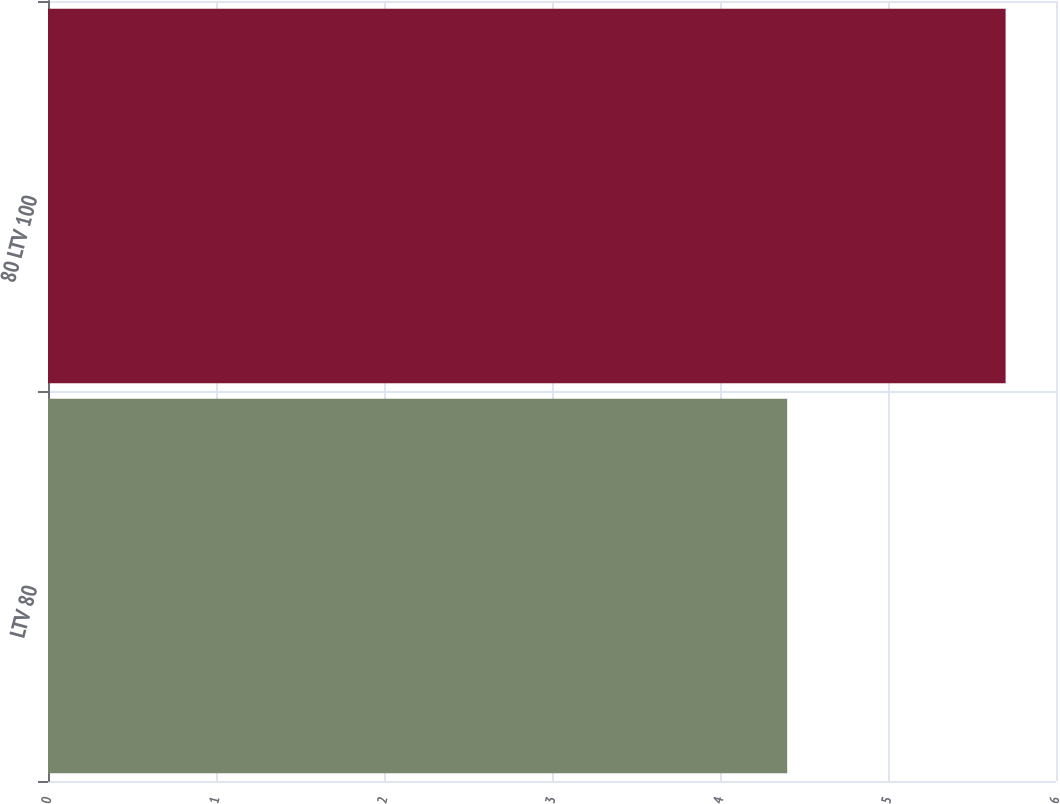Convert chart. <chart><loc_0><loc_0><loc_500><loc_500><bar_chart><fcel>LTV 80<fcel>80 LTV 100<nl><fcel>4.4<fcel>5.7<nl></chart> 